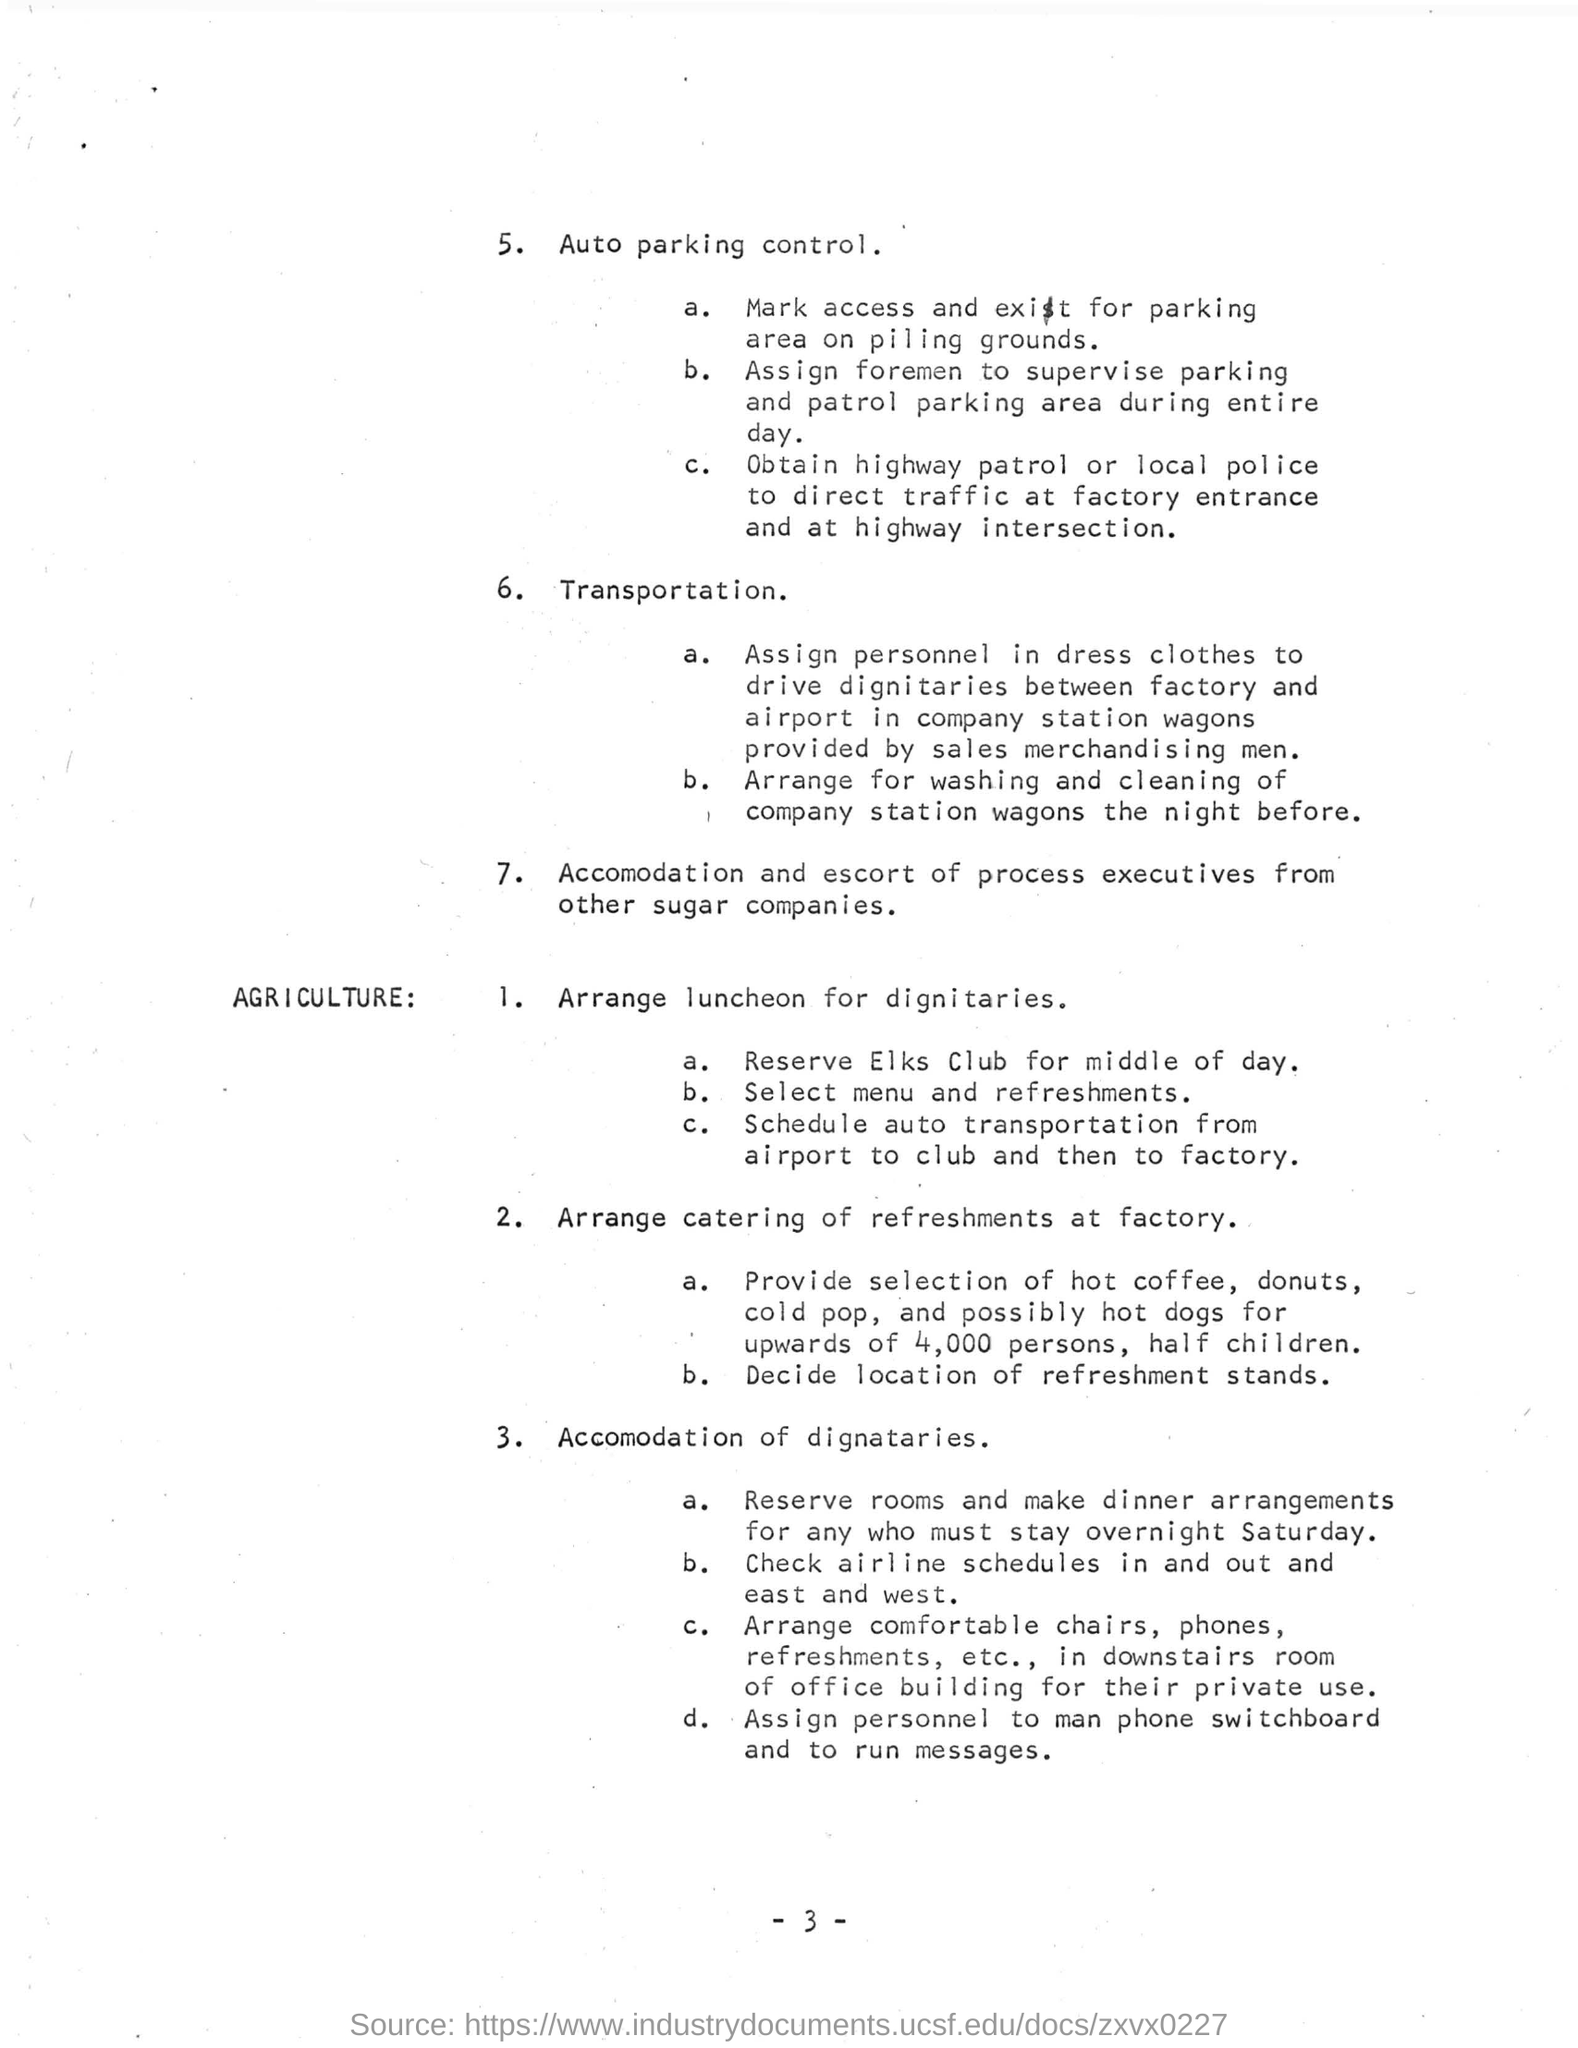Accomodation and escort of process executives from which companies?
Offer a very short reply. Other sugar companies. For whom are transportation arrangements  made from airport to club and then to factory?
Offer a terse response. DIGNITARIES. 